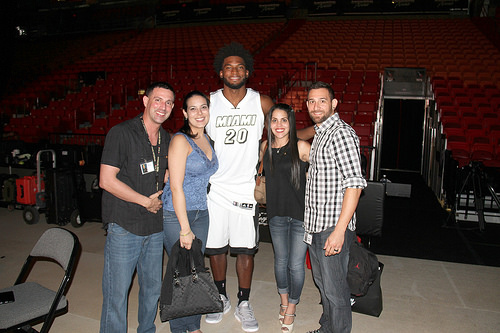<image>
Can you confirm if the chair is above the floor? No. The chair is not positioned above the floor. The vertical arrangement shows a different relationship. 